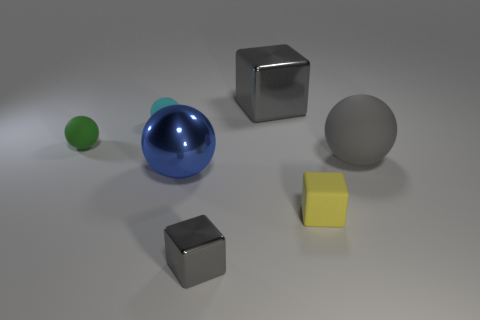Is the size of the yellow object the same as the shiny cube that is in front of the cyan ball?
Your response must be concise. Yes. What is the size of the ball that is in front of the small green rubber object and to the left of the gray matte thing?
Your response must be concise. Large. Is there a tiny thing of the same color as the small rubber block?
Offer a very short reply. No. The metallic thing left of the shiny object that is in front of the blue metallic ball is what color?
Offer a very short reply. Blue. Is the number of small rubber things that are left of the blue sphere less than the number of small things that are behind the small yellow rubber block?
Your response must be concise. No. Is the blue thing the same size as the cyan ball?
Your response must be concise. No. The metal object that is both behind the yellow rubber block and to the left of the large gray block has what shape?
Make the answer very short. Sphere. How many large green cylinders have the same material as the large gray cube?
Offer a very short reply. 0. How many tiny cyan balls are behind the large ball that is in front of the large gray rubber sphere?
Your response must be concise. 1. What shape is the gray thing that is to the right of the tiny block behind the gray thing that is in front of the blue ball?
Your response must be concise. Sphere. 